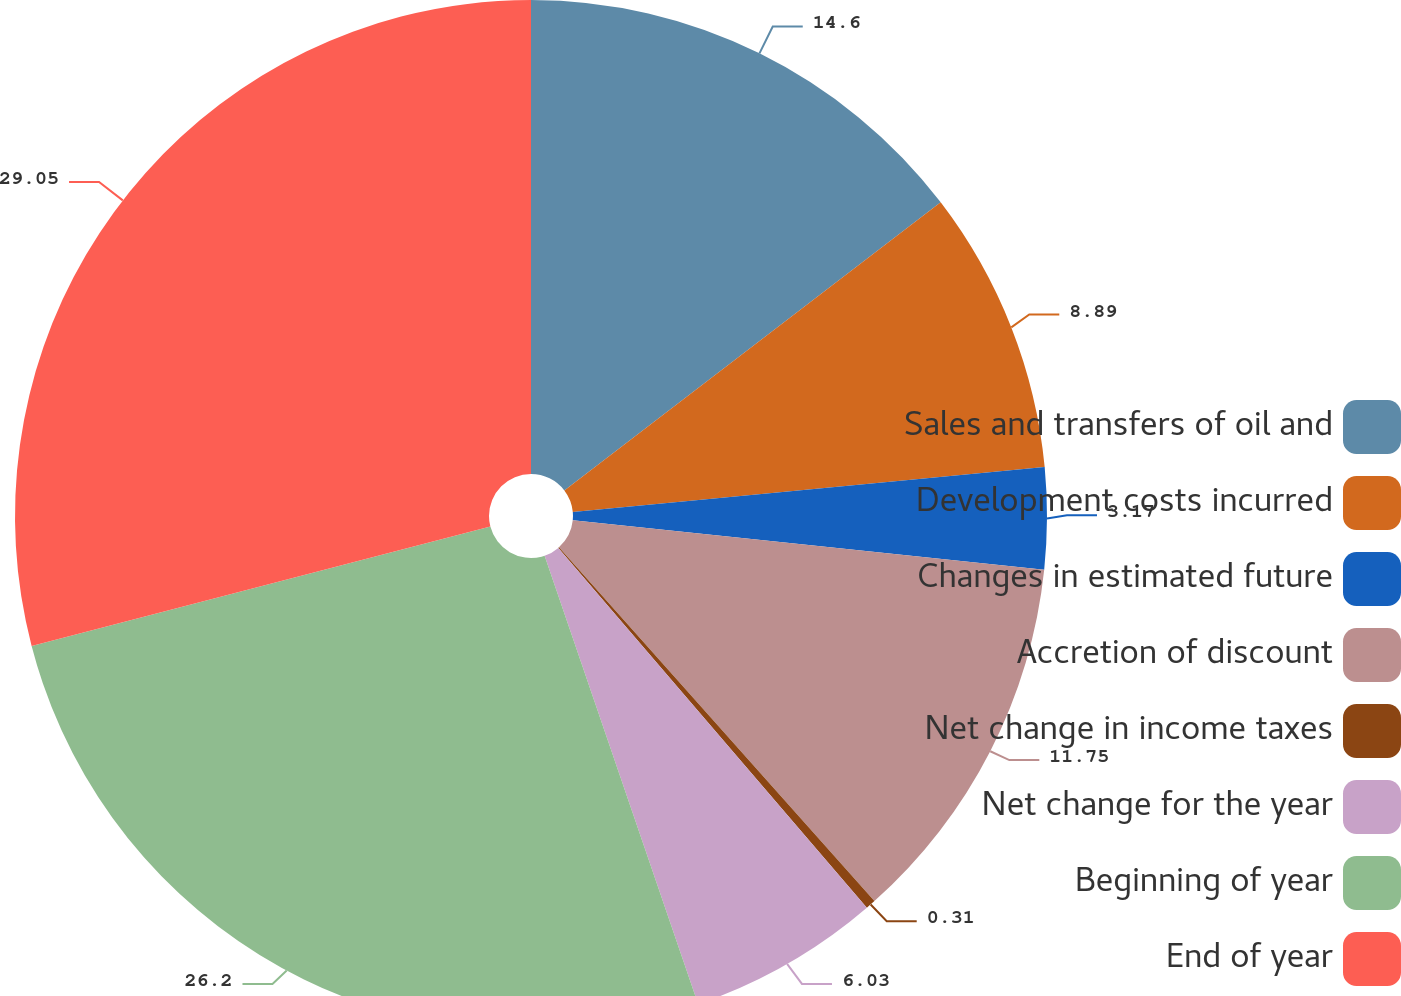<chart> <loc_0><loc_0><loc_500><loc_500><pie_chart><fcel>Sales and transfers of oil and<fcel>Development costs incurred<fcel>Changes in estimated future<fcel>Accretion of discount<fcel>Net change in income taxes<fcel>Net change for the year<fcel>Beginning of year<fcel>End of year<nl><fcel>14.6%<fcel>8.89%<fcel>3.17%<fcel>11.75%<fcel>0.31%<fcel>6.03%<fcel>26.2%<fcel>29.05%<nl></chart> 